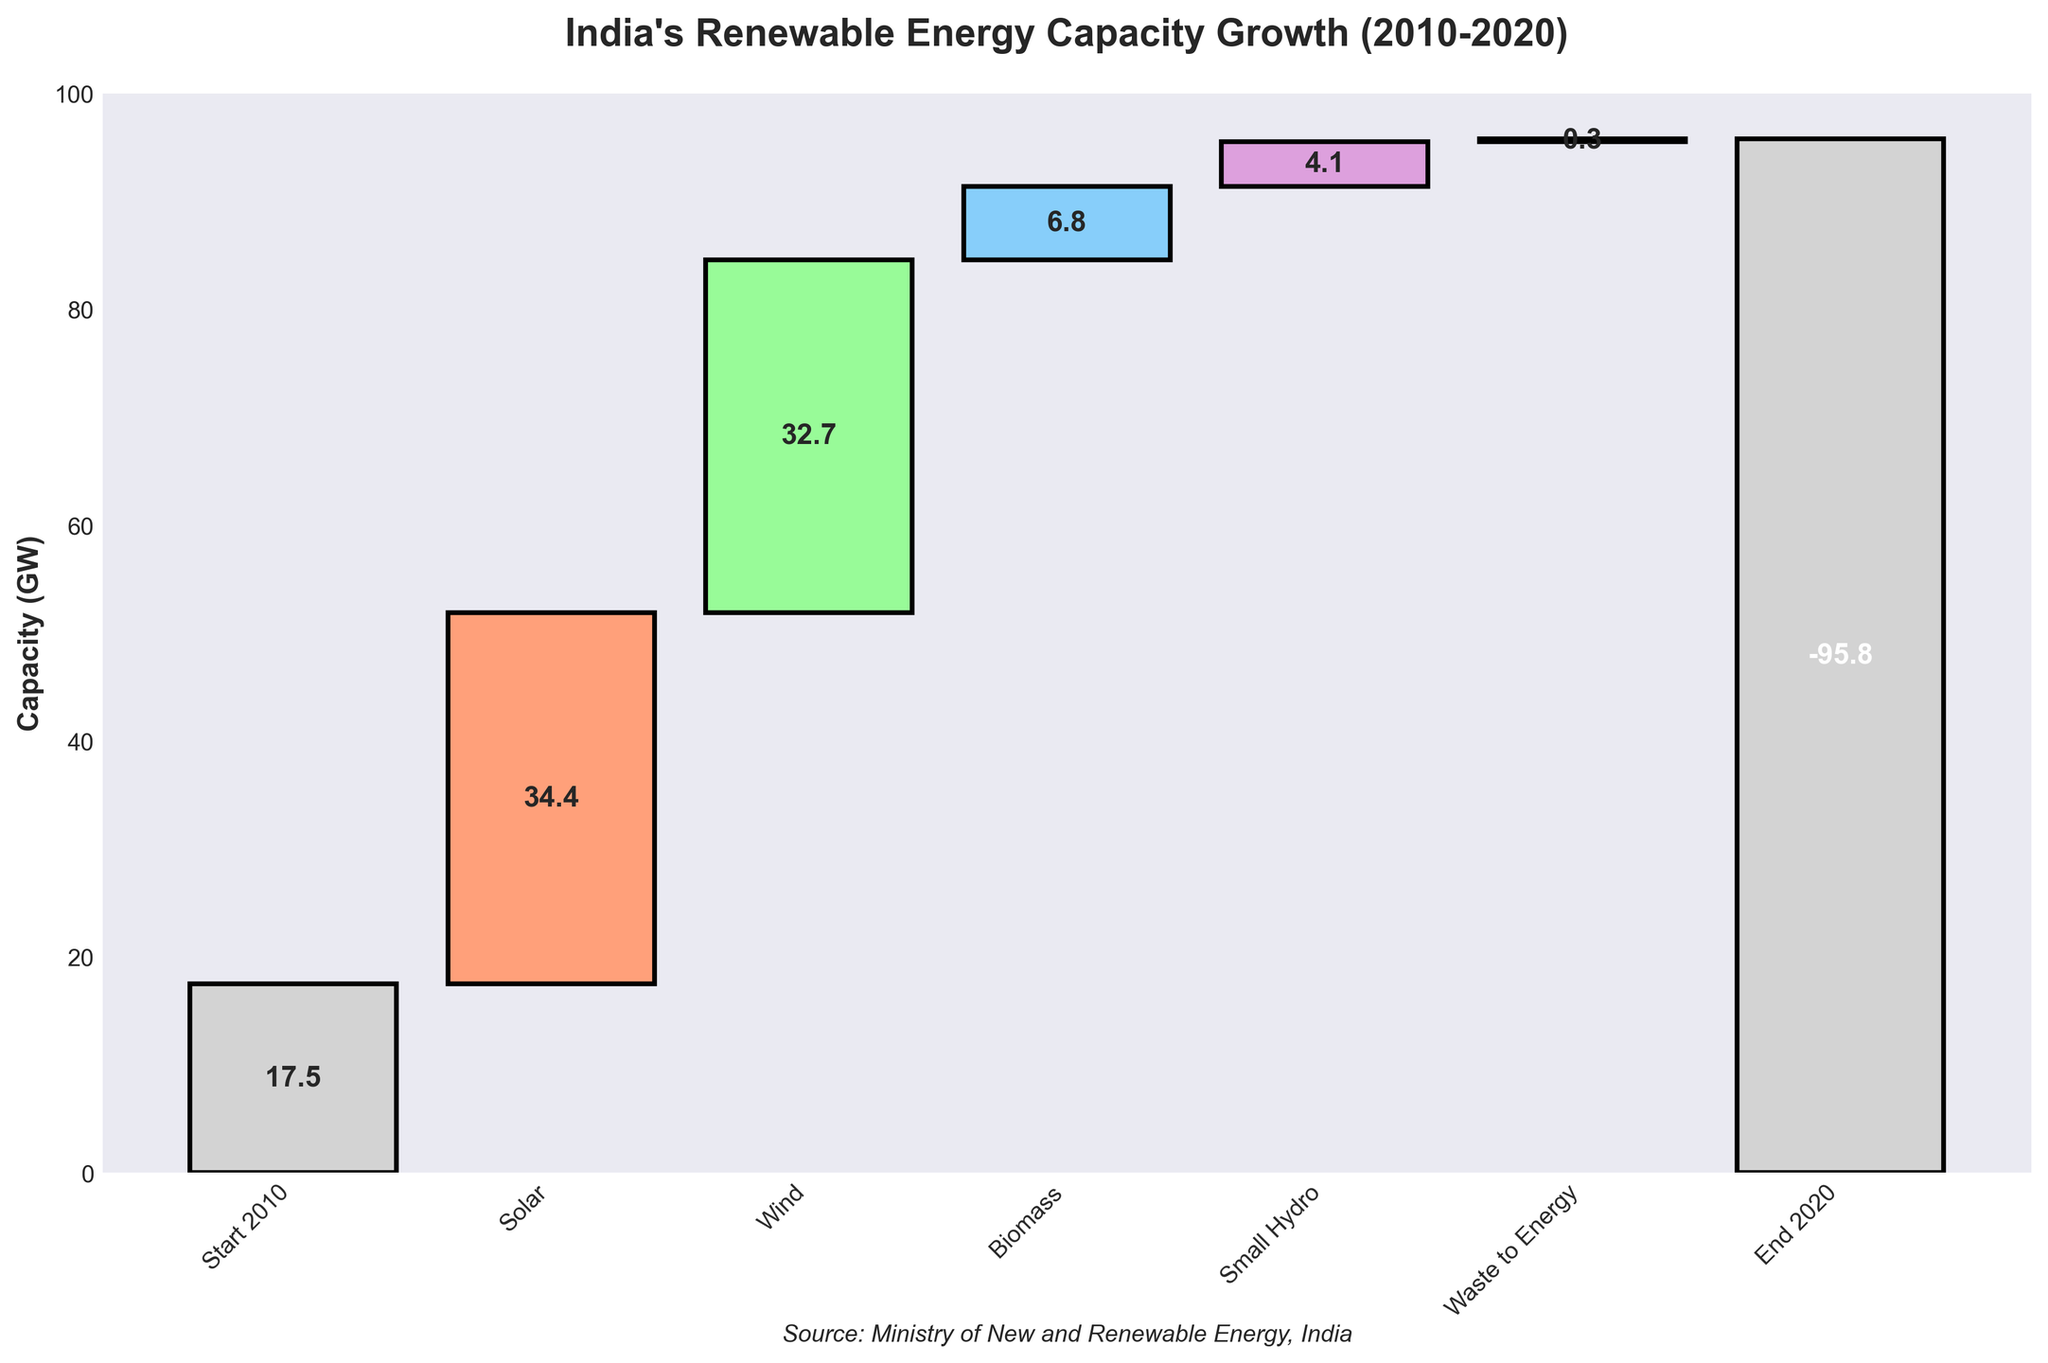What is the start value of India's renewable energy capacity in 2010? The start value is directly indicated under the "Start 2010" category.
Answer: 17.5 GW What is the title of the waterfall chart? The title is displayed at the top of the chart.
Answer: India's Renewable Energy Capacity Growth (2010-2020) How much capacity did solar energy add to India's renewable energy capacity between 2010 and 2020? Look for the "Solar" category and its corresponding value, which is 34.4 GW.
Answer: 34.4 GW What's the cumulative growth in renewable energy capacity from wind and biomass? Sum the values of the "Wind" and "Biomass" categories: 32.7 GW + 6.8 GW.
Answer: 39.5 GW Which energy source contributed the least to India's renewable energy capacity growth between 2010 and 2020? Identify the category with the smallest value; "Waste to Energy" has the smallest contribution of 0.3 GW.
Answer: Waste to Energy How does the contribution of small hydro compare to biomass in terms of renewable energy capacity addition? Compare the values under "Small Hydro" (4.1 GW) and "Biomass" (6.8 GW). Biomass contributed more.
Answer: Biomass What is the overall increase in India's renewable energy capacity from 2010 to 2020? Add up all the contributions from Solar, Wind, Biomass, Small Hydro, and Waste to Energy: 34.4 + 32.7 + 6.8 + 4.1 + 0.3, and subtract the negative "End 2020" value from the summed up value: (34.4 + 32.7 + 6.8 + 4.1 + 0.3 - 95.8)
Answer: -17.5 GW What percentage contribution did wind energy make to the total renewable energy capacity growth, excluding initial and final values? Calculate the total of the positive contributions first: 34.4 + 32.7 + 6.8 + 4.1 + 0.3 = 78.3 GW. Wind's percentage contribution is (32.7 / 78.3) * 100 %.
Answer: 41.76% What is the final renewable energy capacity in India in 2020? The final value is indicated under the "End 2020" category, but the value is negative and shows a reduction by that amount, so relative cumulative growth should be calculated and mentioned.
Answer: -95.8 GW 